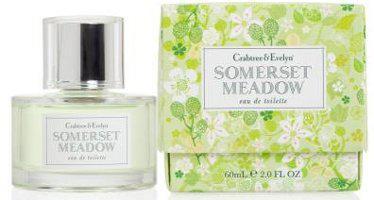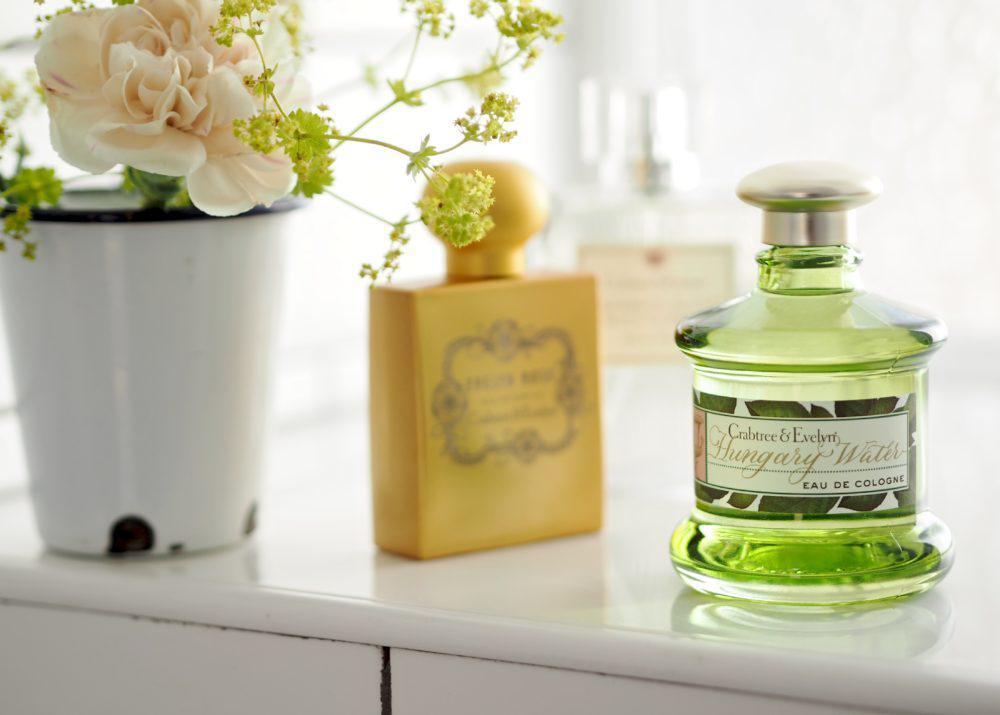The first image is the image on the left, the second image is the image on the right. Analyze the images presented: Is the assertion "In the image to the right, the fragrance bottle is a different color than its box." valid? Answer yes or no. No. The first image is the image on the left, the second image is the image on the right. Considering the images on both sides, is "there are two perfume bottles in the image pair" valid? Answer yes or no. No. 